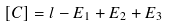<formula> <loc_0><loc_0><loc_500><loc_500>[ C ] = l - E _ { 1 } + E _ { 2 } + E _ { 3 }</formula> 